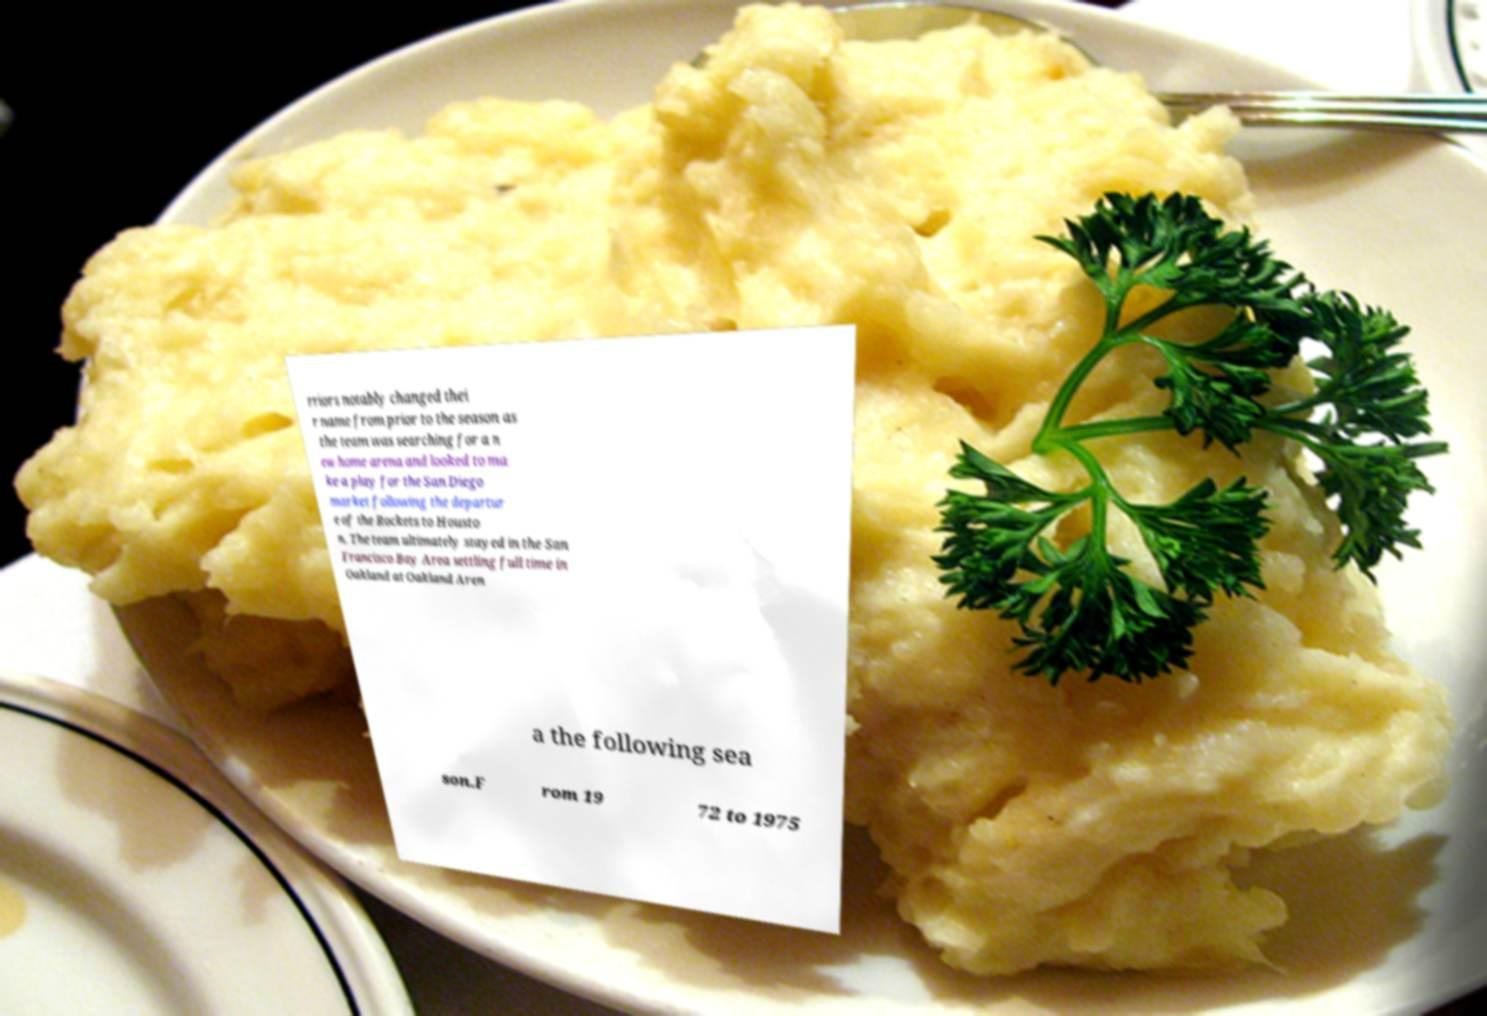Please identify and transcribe the text found in this image. rriors notably changed thei r name from prior to the season as the team was searching for a n ew home arena and looked to ma ke a play for the San Diego market following the departur e of the Rockets to Housto n. The team ultimately stayed in the San Francisco Bay Area settling full time in Oakland at Oakland Aren a the following sea son.F rom 19 72 to 1975 